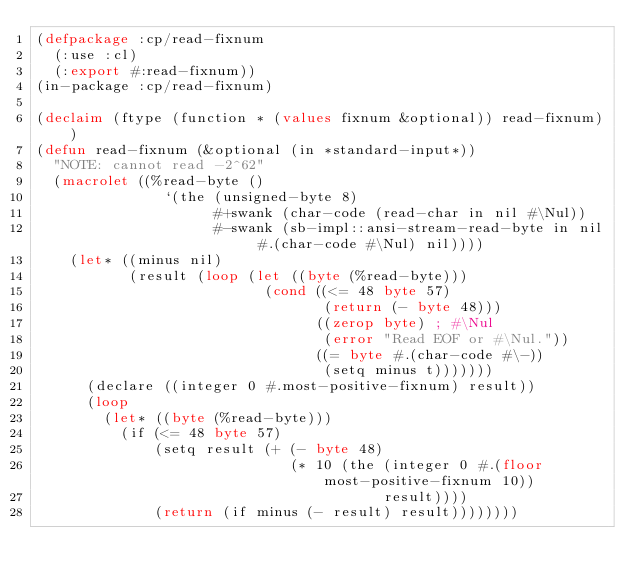<code> <loc_0><loc_0><loc_500><loc_500><_Lisp_>(defpackage :cp/read-fixnum
  (:use :cl)
  (:export #:read-fixnum))
(in-package :cp/read-fixnum)

(declaim (ftype (function * (values fixnum &optional)) read-fixnum))
(defun read-fixnum (&optional (in *standard-input*))
  "NOTE: cannot read -2^62"
  (macrolet ((%read-byte ()
               `(the (unsigned-byte 8)
                     #+swank (char-code (read-char in nil #\Nul))
                     #-swank (sb-impl::ansi-stream-read-byte in nil #.(char-code #\Nul) nil))))
    (let* ((minus nil)
           (result (loop (let ((byte (%read-byte)))
                           (cond ((<= 48 byte 57)
                                  (return (- byte 48)))
                                 ((zerop byte) ; #\Nul
                                  (error "Read EOF or #\Nul."))
                                 ((= byte #.(char-code #\-))
                                  (setq minus t)))))))
      (declare ((integer 0 #.most-positive-fixnum) result))
      (loop
        (let* ((byte (%read-byte)))
          (if (<= 48 byte 57)
              (setq result (+ (- byte 48)
                              (* 10 (the (integer 0 #.(floor most-positive-fixnum 10))
                                         result))))
              (return (if minus (- result) result))))))))
</code> 